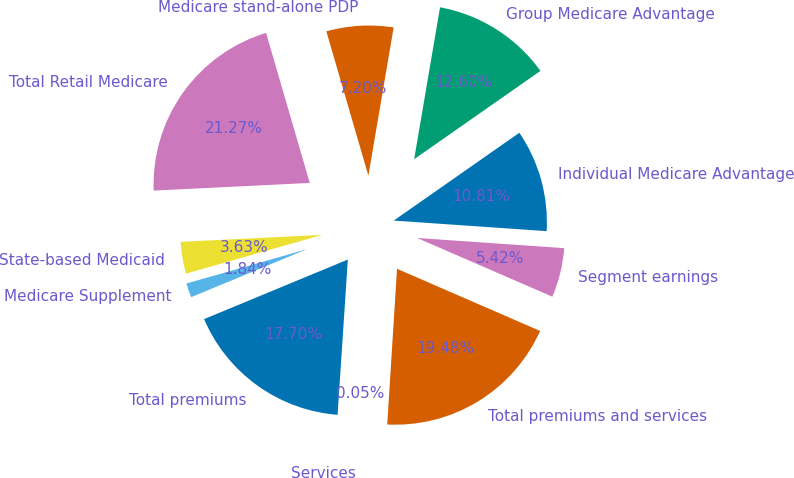Convert chart to OTSL. <chart><loc_0><loc_0><loc_500><loc_500><pie_chart><fcel>Individual Medicare Advantage<fcel>Group Medicare Advantage<fcel>Medicare stand-alone PDP<fcel>Total Retail Medicare<fcel>State-based Medicaid<fcel>Medicare Supplement<fcel>Total premiums<fcel>Services<fcel>Total premiums and services<fcel>Segment earnings<nl><fcel>10.81%<fcel>12.6%<fcel>7.2%<fcel>21.27%<fcel>3.63%<fcel>1.84%<fcel>17.7%<fcel>0.05%<fcel>19.48%<fcel>5.42%<nl></chart> 